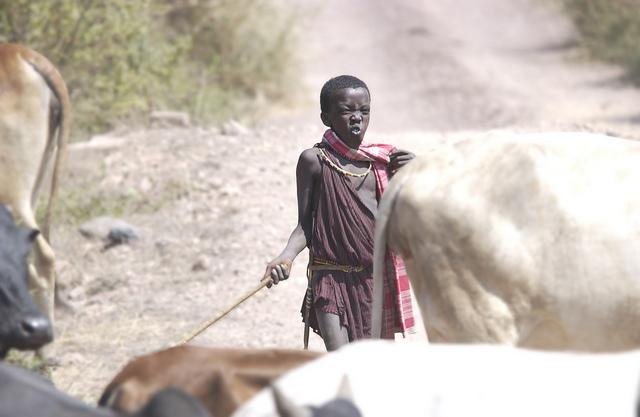What is this kid responsible for? herding cows 